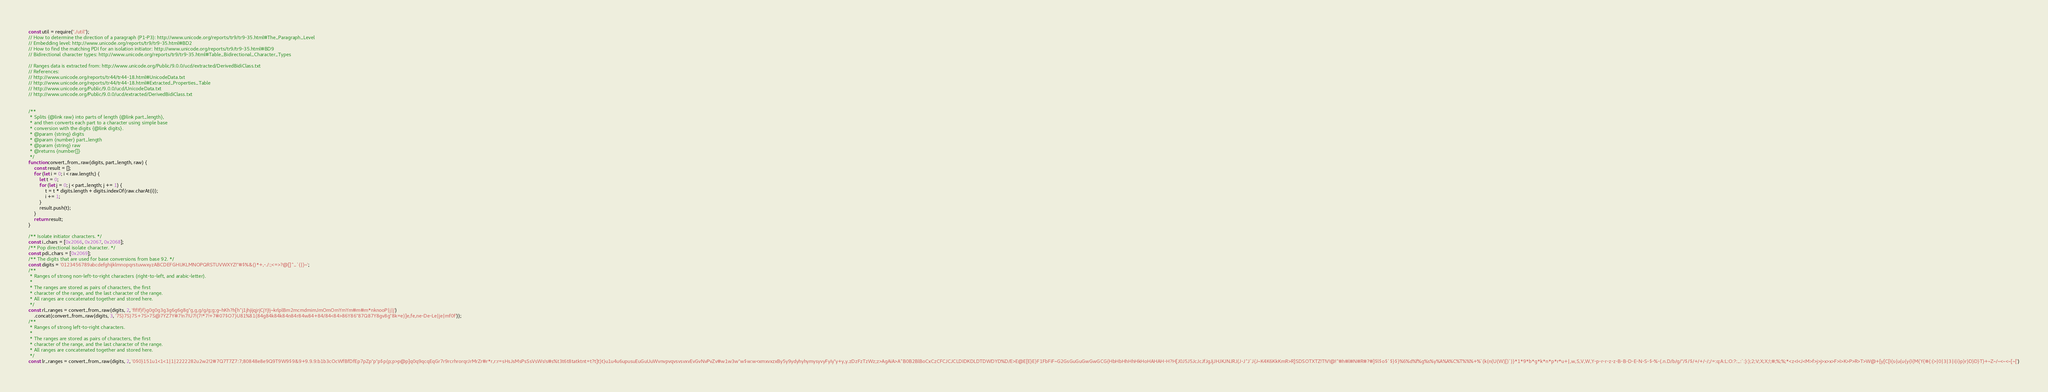Convert code to text. <code><loc_0><loc_0><loc_500><loc_500><_JavaScript_>const util = require("./util");
// How to determine the direction of a paragraph (P1-P3): http://www.unicode.org/reports/tr9/tr9-35.html#The_Paragraph_Level
// Embedding level: http://www.unicode.org/reports/tr9/tr9-35.html#BD2
// How to find the matching PDI for an isolation initiator: http://www.unicode.org/reports/tr9/tr9-35.html#BD9
// Bidirectional character types: http://www.unicode.org/reports/tr9/tr9-35.html#Table_Bidirectional_Character_Types

// Ranges data is extracted from: http://www.unicode.org/Public/9.0.0/ucd/extracted/DerivedBidiClass.txt
// References:
// http://www.unicode.org/reports/tr44/tr44-18.html#UnicodeData.txt
// http://www.unicode.org/reports/tr44/tr44-18.html#Extracted_Properties_Table
// http://www.unicode.org/Public/9.0.0/ucd/UnicodeData.txt
// http://www.unicode.org/Public/9.0.0/ucd/extracted/DerivedBidiClass.txt


/**
 * Splits {@link raw} into parts of length {@link part_length},
 * and then converts each part to a character using simple base
 * conversion with the digits {@link digits}.
 * @param {string} digits
 * @param {number} part_length
 * @param {string} raw
 * @returns {number[]}
 */
function convert_from_raw(digits, part_length, raw) {
    const result = [];
    for (let i = 0; i < raw.length;) {
        let t = 0;
        for (let j = 0; j < part_length; j += 1) {
            t = t * digits.length + digits.indexOf(raw.charAt(i));
            i += 1;
        }
        result.push(t);
    }
    return result;
}

/** Isolate initiator characters. */
const i_chars = [0x2066, 0x2067, 0x2068];
/** Pop directional isolate character. */
const pdi_chars = [0x2069];
/** The digits that are used for base conversions from base 92. */
const digits = '0123456789abcdefghijklmnopqrstuvwxyzABCDEFGHIJKLMNOPQRSTUVWXYZ!"#$%&()*+,-./:;<=>?@[]^_`{|}~';
/**
 * Ranges of strong non-left-to-right characters (right-to-left, and arabic-letter).
 *
 * The ranges are stored as pairs of characters, the first
 * character of the range, and the last character of the range.
 * All ranges are concatenated together and stored here.
 */
const rl_ranges = convert_from_raw(digits, 2, 'fIfIf}f}g0g0g3g3g6g6g8g"g,g,g/g/g;g;g~hKh?h[h^j1jhjijqjrjCjYj!j~krlplBm2mcmdmimJmOmOmYmYm#m#m*nknooP|j|j')
    .concat(convert_from_raw(digits, 3, '7S)7S)7S+7S>7S@7YZ7Y#7!n7!U7!(7!*7!+7#07$O7}U81%81(84g84k84k84n84r84w84+84/84<84>86Y86"87Q87Y8gv8g"8k=e)]e,fe,ne-De-Le|je|mf0f'));
/**
 * Ranges of strong left-to-right characters.
 *
 * The ranges are stored as pairs of characters, the first
 * character of the range, and the last character of the range.
 * All ranges are concatenated together and stored here.
 */
const lr_ranges = convert_from_raw(digits, 2, '0$0}151u1<1<1|1|2222282u2w2!2#7Q7T7Z7:7;80848e8e9Q9T9W9$9&9+9.9.9:b1b3cOcWfBfDfEp7pZp"p"p$p(p;p>p@p]q0q9qcqEqGr7r9rcrhrorqrJrMrZr#r*r,r:r=sHsJsMsPsSsVsWs!s#s%t3t6t8tatktnt=t?t]t}t}u1u4u6upusuEuGuUuWvnvpvqvsvsvxvEvGvNvPvZv#w1w3w"w$w:w<xmxvxzxBy5y9ydyhyhymysyvyFyIy"y+y,y.zDzFzTzWz;z>AgAiA>A^B0B2BlBoCxCzCFCJCJCLDIDKDLDTDWDYD%D/E>E@E[E}E}F1FbFiF~G2GsGuGuGwGwGCG{HbHbHhHhHkHoHAHAH-H?H[J0J5J5JcJcJfJgJjJHJKJNJRJ(J-J^J`J{J~K4K6KkKmR>R]SDSOTXTZ!T!V!@!^#h#l#N#R#?#]$l$o$`$}$}%6%d%f%g%s%y%A%A%C%T%%%+%`(k(n(U(W)[)`)}*1*9*b*g*k*n*p*r*u+|,w,S,V,W,Y-p-r-r-z-z-B-B-D-E-N-S-$-%-(.n.D/b/g/"/$/$/+/+/-/;/=:q:A:L:O:?:_:`:}:};2;V;X;X;!;#;%;%;*<z<I<J<M>f>j>j>x>x>F>I>K>P>R>T>W@+[y[C[I{s{u{u{y{I{M{Y{#{:{>|0|3|3|i|i}p}r}D}D}T}+~Z~/~<~<~[~[')</code> 